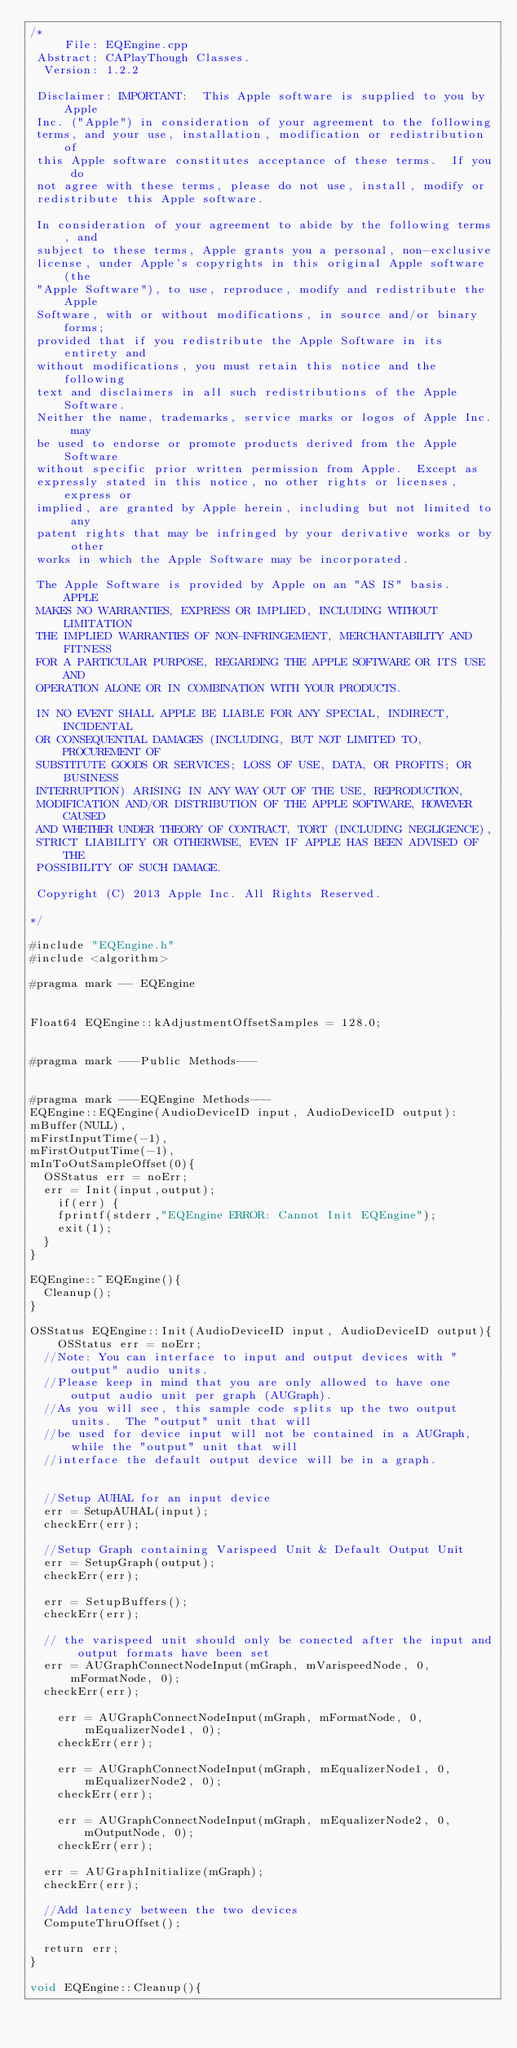<code> <loc_0><loc_0><loc_500><loc_500><_ObjectiveC_>/*
     File: EQEngine.cpp 
 Abstract: CAPlayThough Classes. 
  Version: 1.2.2 
  
 Disclaimer: IMPORTANT:  This Apple software is supplied to you by Apple 
 Inc. ("Apple") in consideration of your agreement to the following 
 terms, and your use, installation, modification or redistribution of 
 this Apple software constitutes acceptance of these terms.  If you do 
 not agree with these terms, please do not use, install, modify or 
 redistribute this Apple software. 
  
 In consideration of your agreement to abide by the following terms, and 
 subject to these terms, Apple grants you a personal, non-exclusive 
 license, under Apple's copyrights in this original Apple software (the 
 "Apple Software"), to use, reproduce, modify and redistribute the Apple 
 Software, with or without modifications, in source and/or binary forms; 
 provided that if you redistribute the Apple Software in its entirety and 
 without modifications, you must retain this notice and the following 
 text and disclaimers in all such redistributions of the Apple Software. 
 Neither the name, trademarks, service marks or logos of Apple Inc. may 
 be used to endorse or promote products derived from the Apple Software 
 without specific prior written permission from Apple.  Except as 
 expressly stated in this notice, no other rights or licenses, express or 
 implied, are granted by Apple herein, including but not limited to any 
 patent rights that may be infringed by your derivative works or by other 
 works in which the Apple Software may be incorporated. 
  
 The Apple Software is provided by Apple on an "AS IS" basis.  APPLE 
 MAKES NO WARRANTIES, EXPRESS OR IMPLIED, INCLUDING WITHOUT LIMITATION 
 THE IMPLIED WARRANTIES OF NON-INFRINGEMENT, MERCHANTABILITY AND FITNESS 
 FOR A PARTICULAR PURPOSE, REGARDING THE APPLE SOFTWARE OR ITS USE AND 
 OPERATION ALONE OR IN COMBINATION WITH YOUR PRODUCTS. 
  
 IN NO EVENT SHALL APPLE BE LIABLE FOR ANY SPECIAL, INDIRECT, INCIDENTAL 
 OR CONSEQUENTIAL DAMAGES (INCLUDING, BUT NOT LIMITED TO, PROCUREMENT OF 
 SUBSTITUTE GOODS OR SERVICES; LOSS OF USE, DATA, OR PROFITS; OR BUSINESS 
 INTERRUPTION) ARISING IN ANY WAY OUT OF THE USE, REPRODUCTION, 
 MODIFICATION AND/OR DISTRIBUTION OF THE APPLE SOFTWARE, HOWEVER CAUSED 
 AND WHETHER UNDER THEORY OF CONTRACT, TORT (INCLUDING NEGLIGENCE), 
 STRICT LIABILITY OR OTHERWISE, EVEN IF APPLE HAS BEEN ADVISED OF THE 
 POSSIBILITY OF SUCH DAMAGE. 
  
 Copyright (C) 2013 Apple Inc. All Rights Reserved. 
  
*/ 

#include "EQEngine.h"
#include <algorithm>

#pragma mark -- EQEngine


Float64 EQEngine::kAdjustmentOffsetSamples = 128.0;


#pragma mark ---Public Methods---


#pragma mark ---EQEngine Methods---
EQEngine::EQEngine(AudioDeviceID input, AudioDeviceID output):
mBuffer(NULL),
mFirstInputTime(-1),
mFirstOutputTime(-1),
mInToOutSampleOffset(0){
	OSStatus err = noErr;
	err = Init(input,output);
    if(err) {
		fprintf(stderr,"EQEngine ERROR: Cannot Init EQEngine");
		exit(1);
	}
}

EQEngine::~EQEngine(){
	Cleanup();
}

OSStatus EQEngine::Init(AudioDeviceID input, AudioDeviceID output){
    OSStatus err = noErr;
	//Note: You can interface to input and output devices with "output" audio units.
	//Please keep in mind that you are only allowed to have one output audio unit per graph (AUGraph).
	//As you will see, this sample code splits up the two output units.  The "output" unit that will
	//be used for device input will not be contained in a AUGraph, while the "output" unit that will 
	//interface the default output device will be in a graph.
    
    
	//Setup AUHAL for an input device
	err = SetupAUHAL(input);
	checkErr(err);

	//Setup Graph containing Varispeed Unit & Default Output Unit
	err = SetupGraph(output);
	checkErr(err);
	
	err = SetupBuffers();
	checkErr(err);
	
	// the varispeed unit should only be conected after the input and output formats have been set
	err = AUGraphConnectNodeInput(mGraph, mVarispeedNode, 0, mFormatNode, 0);
	checkErr(err);
    
    err = AUGraphConnectNodeInput(mGraph, mFormatNode, 0, mEqualizerNode1, 0);
    checkErr(err);
    
    err = AUGraphConnectNodeInput(mGraph, mEqualizerNode1, 0, mEqualizerNode2, 0);
    checkErr(err);
    
    err = AUGraphConnectNodeInput(mGraph, mEqualizerNode2, 0, mOutputNode, 0);
    checkErr(err);
	
	err = AUGraphInitialize(mGraph); 
	checkErr(err);
	
	//Add latency between the two devices
	ComputeThruOffset();
		
	return err;	
}

void EQEngine::Cleanup(){</code> 